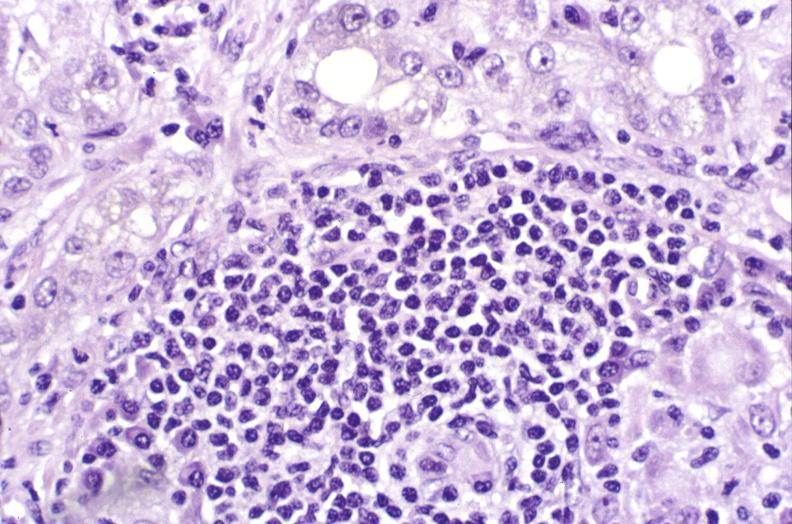s postoperative cardiac surgery present?
Answer the question using a single word or phrase. No 